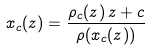Convert formula to latex. <formula><loc_0><loc_0><loc_500><loc_500>x _ { c } ( z ) = \frac { \rho _ { c } ( z ) \, z + c } { \rho ( x _ { c } ( z ) ) }</formula> 